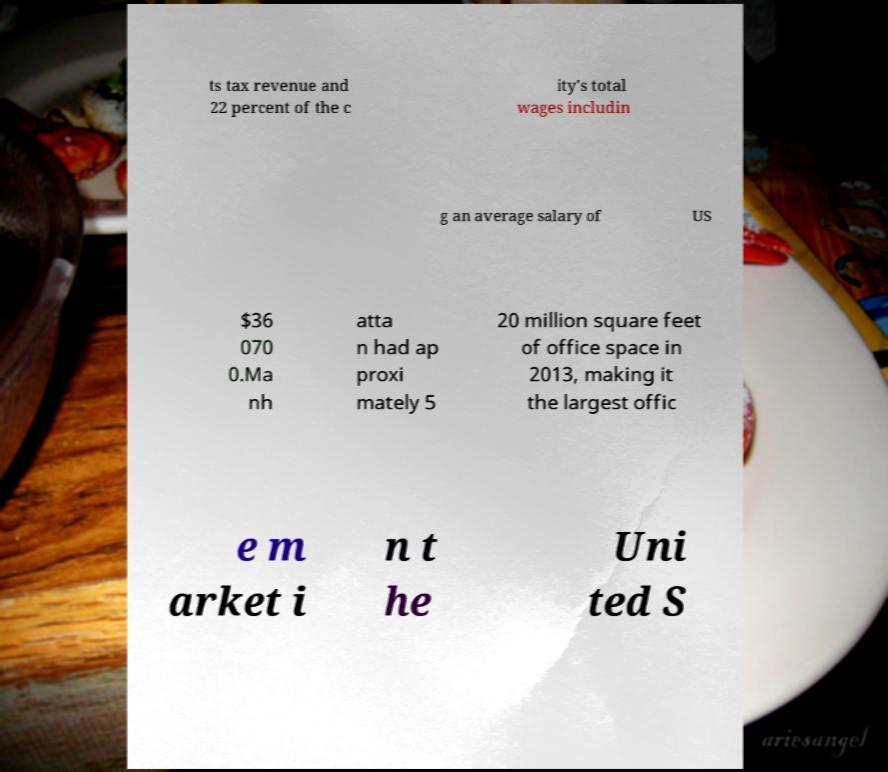Could you extract and type out the text from this image? ts tax revenue and 22 percent of the c ity's total wages includin g an average salary of US $36 070 0.Ma nh atta n had ap proxi mately 5 20 million square feet of office space in 2013, making it the largest offic e m arket i n t he Uni ted S 